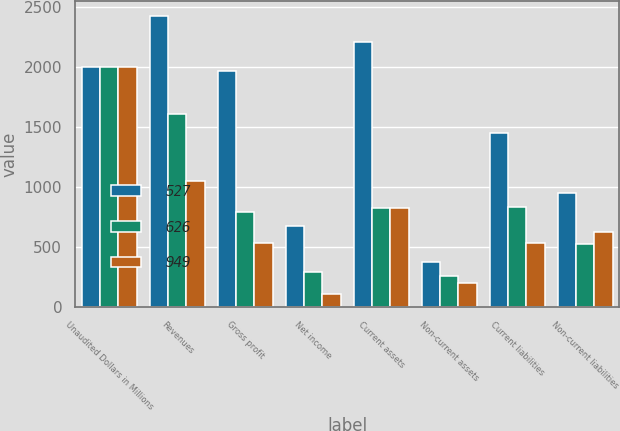Convert chart to OTSL. <chart><loc_0><loc_0><loc_500><loc_500><stacked_bar_chart><ecel><fcel>Unaudited Dollars in Millions<fcel>Revenues<fcel>Gross profit<fcel>Net income<fcel>Current assets<fcel>Non-current assets<fcel>Current liabilities<fcel>Non-current liabilities<nl><fcel>527<fcel>2004<fcel>2427<fcel>1965<fcel>673<fcel>2206<fcel>371<fcel>1447<fcel>949<nl><fcel>626<fcel>2003<fcel>1605<fcel>794<fcel>288<fcel>827<fcel>259<fcel>829<fcel>527<nl><fcel>949<fcel>2002<fcel>1051<fcel>535<fcel>107<fcel>822<fcel>200<fcel>533<fcel>626<nl></chart> 